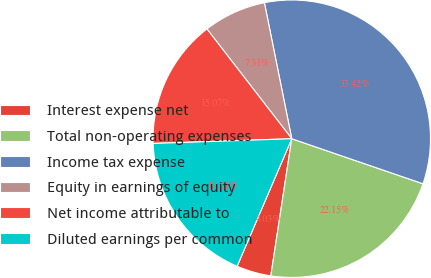<chart> <loc_0><loc_0><loc_500><loc_500><pie_chart><fcel>Interest expense net<fcel>Total non-operating expenses<fcel>Income tax expense<fcel>Equity in earnings of equity<fcel>Net income attributable to<fcel>Diluted earnings per common<nl><fcel>4.03%<fcel>22.15%<fcel>33.42%<fcel>7.31%<fcel>15.07%<fcel>18.01%<nl></chart> 